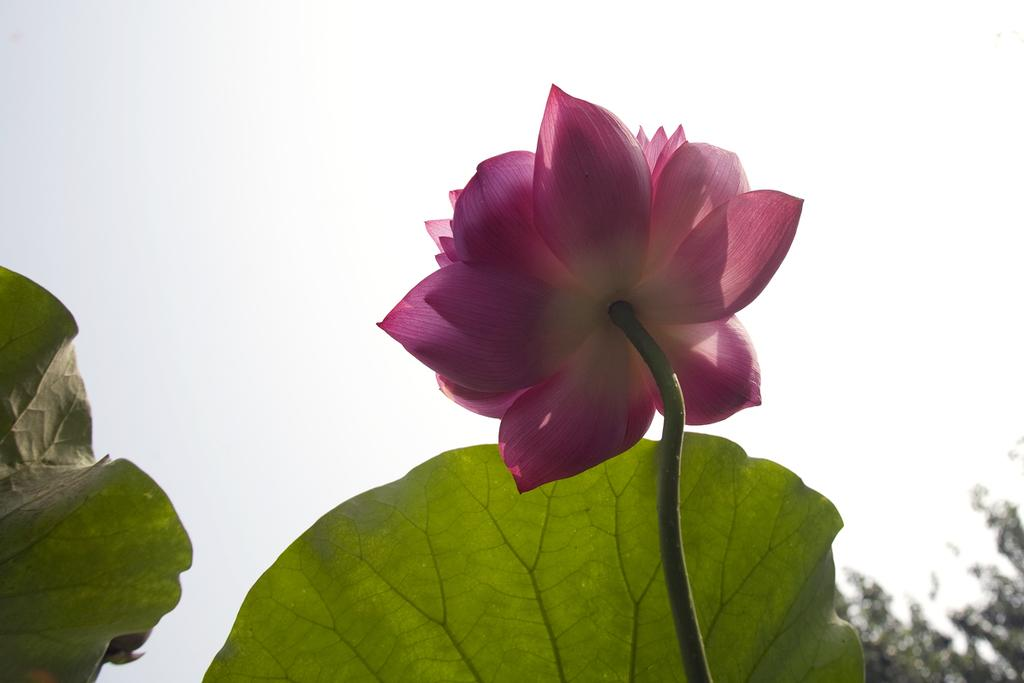What is the main subject of the image? There is a flower on the stem of a plant in the image. What else can be seen in the background of the image? There are leaves and a tree visible in the background of the image. What is the color of the sky in the image? The sky is visible in the background of the image. What type of game is being played by the crow in the image? There is no crow present in the image, and therefore no game being played. What is the mysterious thing that appears in the image? There is no mysterious thing mentioned in the provided facts; the image only contains a flower, leaves, a tree, and the sky. 